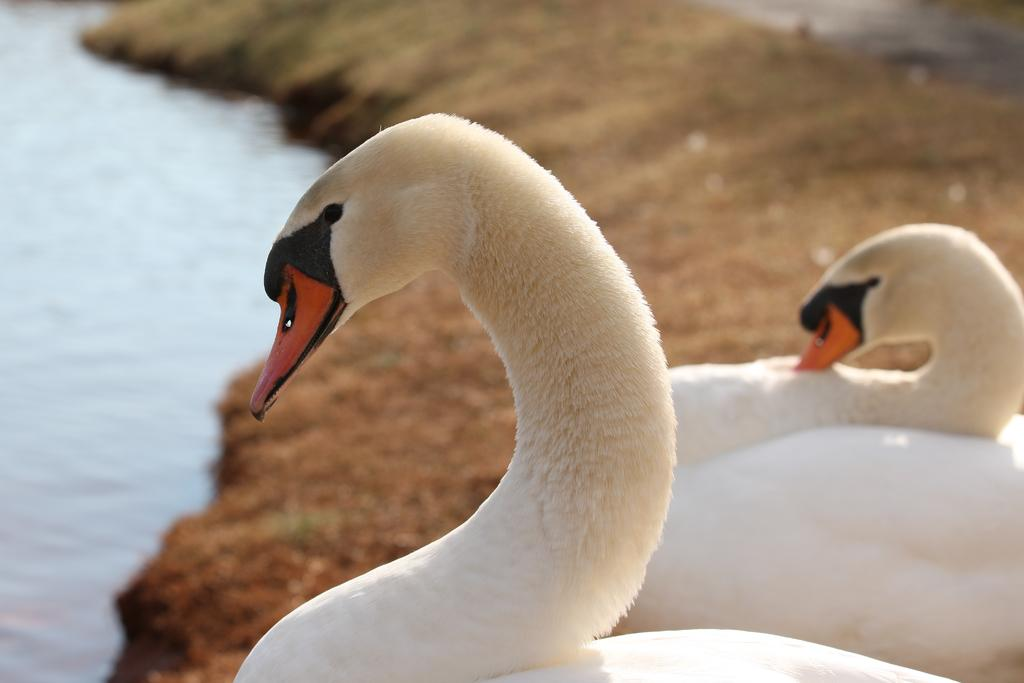What type of animals can be seen on the right side of the image? There are two white color birds on the right side of the image. What is located on the left side of the image? There is water on the left side of the image. What type of vegetation is visible in the background of the image? There is grass on the ground in the background of the image. What decision did the birds make in the image? There is no indication in the image that the birds made any decisions. How are the clouds sorted in the image? There are no clouds present in the image. 